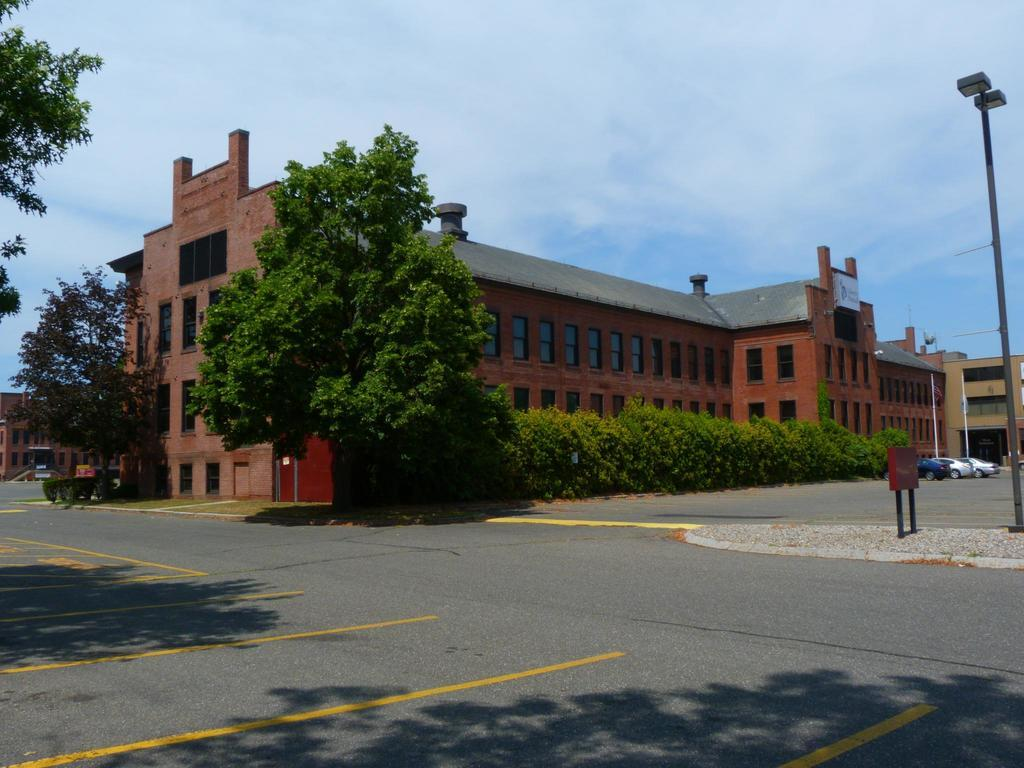What type of vegetation can be seen in the image? There are plants and trees in the image. What structures are present in the image? There are poles, cars, boards, and buildings in the image. What type of pathway is visible in the image? There is a road in the image. What can be seen in the background of the image? The sky is visible in the background of the image. What type of bed can be seen in the image? There is no bed present in the image. What animal can be seen interacting with the cars in the image? There are no animals present in the image; it features plants, trees, poles, cars, boards, buildings, a road, and the sky. 